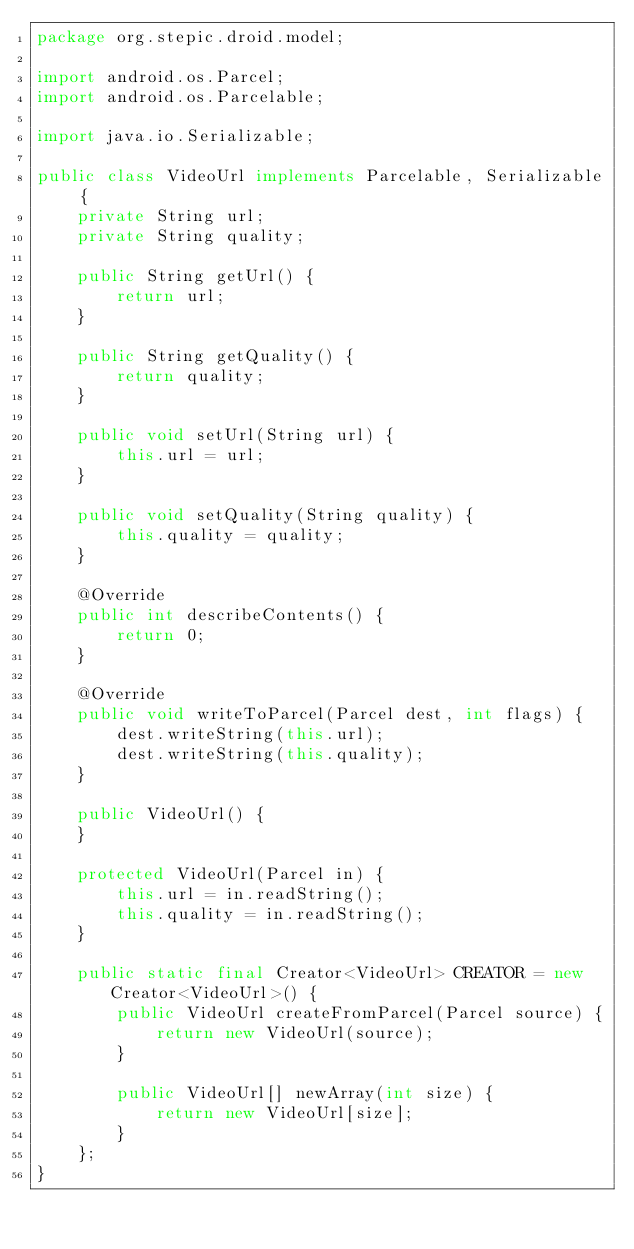<code> <loc_0><loc_0><loc_500><loc_500><_Java_>package org.stepic.droid.model;

import android.os.Parcel;
import android.os.Parcelable;

import java.io.Serializable;

public class VideoUrl implements Parcelable, Serializable {
    private String url;
    private String quality;

    public String getUrl() {
        return url;
    }

    public String getQuality() {
        return quality;
    }

    public void setUrl(String url) {
        this.url = url;
    }

    public void setQuality(String quality) {
        this.quality = quality;
    }

    @Override
    public int describeContents() {
        return 0;
    }

    @Override
    public void writeToParcel(Parcel dest, int flags) {
        dest.writeString(this.url);
        dest.writeString(this.quality);
    }

    public VideoUrl() {
    }

    protected VideoUrl(Parcel in) {
        this.url = in.readString();
        this.quality = in.readString();
    }

    public static final Creator<VideoUrl> CREATOR = new Creator<VideoUrl>() {
        public VideoUrl createFromParcel(Parcel source) {
            return new VideoUrl(source);
        }

        public VideoUrl[] newArray(int size) {
            return new VideoUrl[size];
        }
    };
}
</code> 